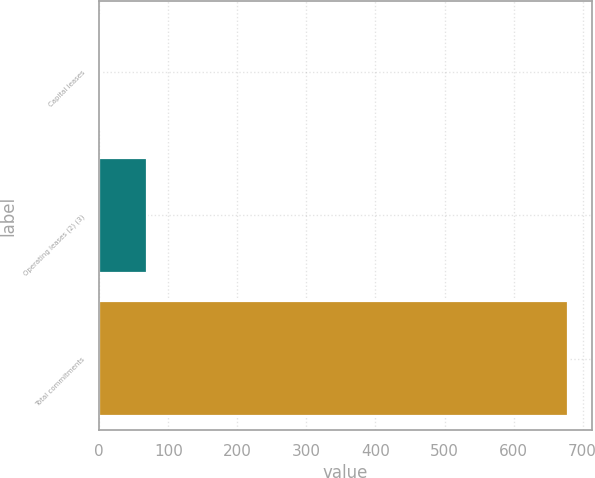Convert chart. <chart><loc_0><loc_0><loc_500><loc_500><bar_chart><fcel>Capital leases<fcel>Operating leases (2) (3)<fcel>Total commitments<nl><fcel>1<fcel>68.8<fcel>679<nl></chart> 